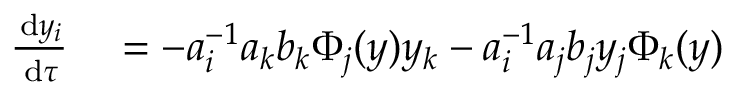Convert formula to latex. <formula><loc_0><loc_0><loc_500><loc_500>\begin{array} { r l } { \frac { \, d y _ { i } } { \, d \tau } } & = - a _ { i } ^ { - 1 } a _ { k } b _ { k } \Phi _ { j } ( y ) y _ { k } - a _ { i } ^ { - 1 } a _ { j } b _ { j } y _ { j } \Phi _ { k } ( y ) } \end{array}</formula> 